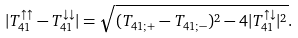<formula> <loc_0><loc_0><loc_500><loc_500>| T _ { 4 1 } ^ { \uparrow \uparrow } - T _ { 4 1 } ^ { \downarrow \downarrow } | = \sqrt { ( T _ { 4 1 ; + } - T _ { 4 1 ; - } ) ^ { 2 } - 4 | T _ { 4 1 } ^ { \uparrow \downarrow } | ^ { 2 } } .</formula> 